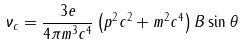Convert formula to latex. <formula><loc_0><loc_0><loc_500><loc_500>\nu _ { c } = \frac { 3 e } { 4 \pi m ^ { 3 } c ^ { 4 } } \left ( p ^ { 2 } c ^ { 2 } + m ^ { 2 } c ^ { 4 } \right ) B \sin \theta</formula> 